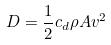<formula> <loc_0><loc_0><loc_500><loc_500>D = \frac { 1 } { 2 } c _ { d } \rho A v ^ { 2 }</formula> 